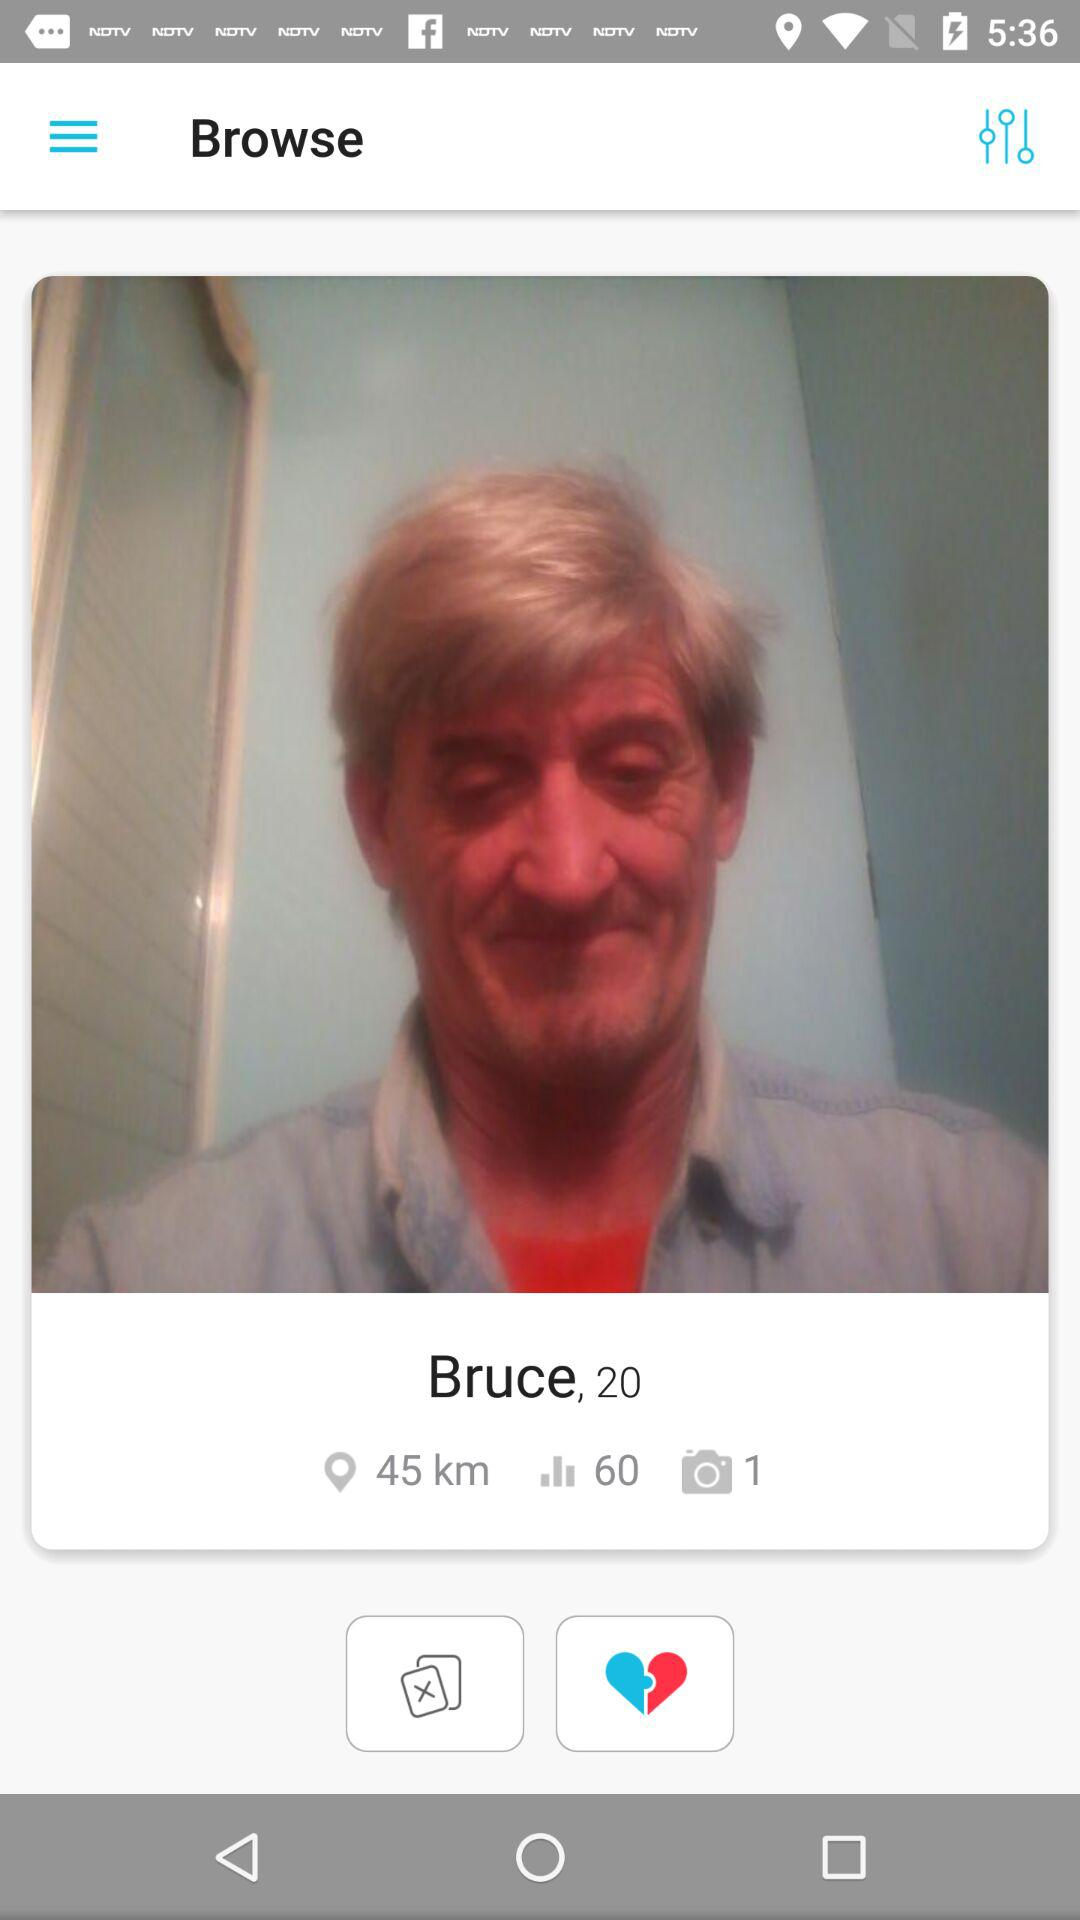What is the name of the person whose image is on the screen? The name of the person is Bruce. 